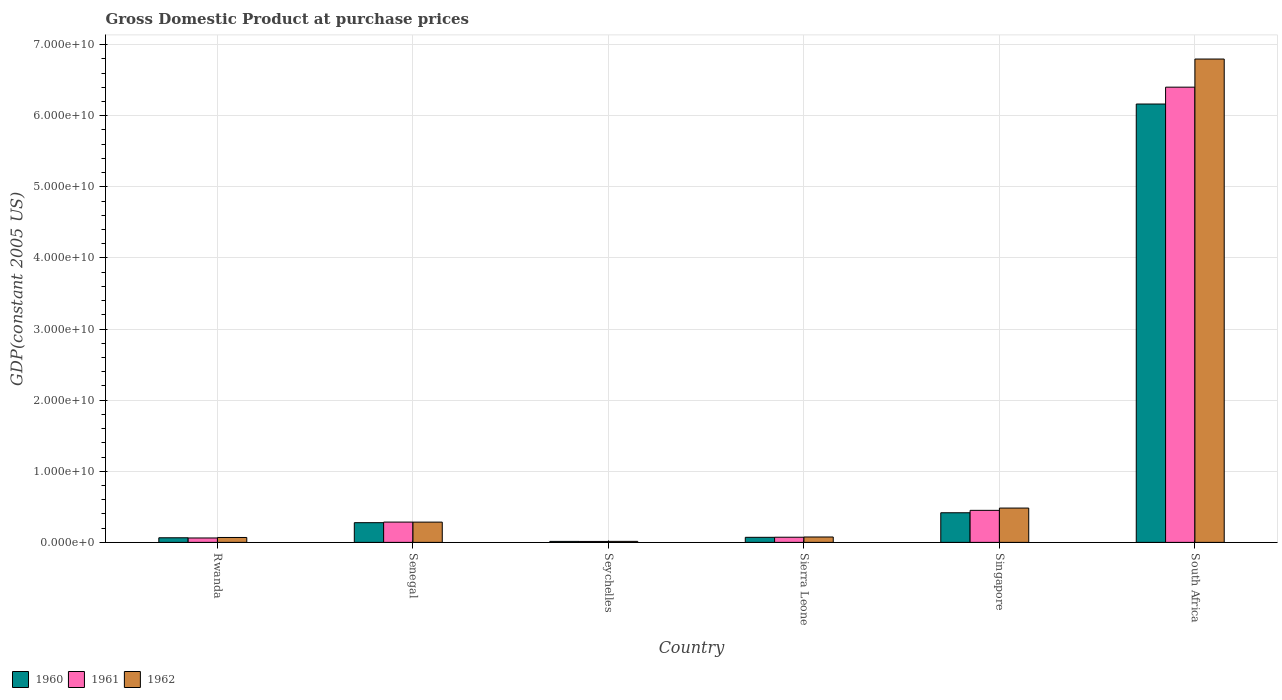How many different coloured bars are there?
Ensure brevity in your answer.  3. Are the number of bars per tick equal to the number of legend labels?
Provide a succinct answer. Yes. Are the number of bars on each tick of the X-axis equal?
Your response must be concise. Yes. How many bars are there on the 6th tick from the right?
Offer a terse response. 3. What is the label of the 2nd group of bars from the left?
Provide a succinct answer. Senegal. In how many cases, is the number of bars for a given country not equal to the number of legend labels?
Your response must be concise. 0. What is the GDP at purchase prices in 1960 in Sierra Leone?
Make the answer very short. 7.13e+08. Across all countries, what is the maximum GDP at purchase prices in 1962?
Offer a terse response. 6.80e+1. Across all countries, what is the minimum GDP at purchase prices in 1961?
Your answer should be very brief. 1.32e+08. In which country was the GDP at purchase prices in 1962 maximum?
Provide a short and direct response. South Africa. In which country was the GDP at purchase prices in 1962 minimum?
Your response must be concise. Seychelles. What is the total GDP at purchase prices in 1961 in the graph?
Your response must be concise. 7.28e+1. What is the difference between the GDP at purchase prices in 1961 in Senegal and that in Sierra Leone?
Give a very brief answer. 2.13e+09. What is the difference between the GDP at purchase prices in 1962 in Seychelles and the GDP at purchase prices in 1961 in Singapore?
Your response must be concise. -4.36e+09. What is the average GDP at purchase prices in 1961 per country?
Keep it short and to the point. 1.21e+1. What is the difference between the GDP at purchase prices of/in 1962 and GDP at purchase prices of/in 1961 in South Africa?
Offer a very short reply. 3.95e+09. In how many countries, is the GDP at purchase prices in 1960 greater than 38000000000 US$?
Give a very brief answer. 1. What is the ratio of the GDP at purchase prices in 1960 in Seychelles to that in Singapore?
Offer a very short reply. 0.03. Is the difference between the GDP at purchase prices in 1962 in Rwanda and Senegal greater than the difference between the GDP at purchase prices in 1961 in Rwanda and Senegal?
Keep it short and to the point. Yes. What is the difference between the highest and the second highest GDP at purchase prices in 1962?
Offer a terse response. -6.51e+1. What is the difference between the highest and the lowest GDP at purchase prices in 1961?
Offer a very short reply. 6.39e+1. What does the 2nd bar from the left in Seychelles represents?
Offer a very short reply. 1961. What does the 2nd bar from the right in Senegal represents?
Your answer should be compact. 1961. Are all the bars in the graph horizontal?
Offer a terse response. No. How many countries are there in the graph?
Offer a terse response. 6. What is the difference between two consecutive major ticks on the Y-axis?
Your response must be concise. 1.00e+1. Are the values on the major ticks of Y-axis written in scientific E-notation?
Offer a very short reply. Yes. How are the legend labels stacked?
Your answer should be compact. Horizontal. What is the title of the graph?
Your answer should be very brief. Gross Domestic Product at purchase prices. Does "1984" appear as one of the legend labels in the graph?
Offer a very short reply. No. What is the label or title of the Y-axis?
Ensure brevity in your answer.  GDP(constant 2005 US). What is the GDP(constant 2005 US) in 1960 in Rwanda?
Make the answer very short. 6.48e+08. What is the GDP(constant 2005 US) of 1961 in Rwanda?
Provide a succinct answer. 6.20e+08. What is the GDP(constant 2005 US) in 1962 in Rwanda?
Make the answer very short. 6.91e+08. What is the GDP(constant 2005 US) of 1960 in Senegal?
Keep it short and to the point. 2.77e+09. What is the GDP(constant 2005 US) in 1961 in Senegal?
Keep it short and to the point. 2.85e+09. What is the GDP(constant 2005 US) in 1962 in Senegal?
Your answer should be very brief. 2.85e+09. What is the GDP(constant 2005 US) in 1960 in Seychelles?
Keep it short and to the point. 1.39e+08. What is the GDP(constant 2005 US) in 1961 in Seychelles?
Your response must be concise. 1.32e+08. What is the GDP(constant 2005 US) of 1962 in Seychelles?
Make the answer very short. 1.43e+08. What is the GDP(constant 2005 US) in 1960 in Sierra Leone?
Offer a terse response. 7.13e+08. What is the GDP(constant 2005 US) of 1961 in Sierra Leone?
Provide a succinct answer. 7.25e+08. What is the GDP(constant 2005 US) of 1962 in Sierra Leone?
Give a very brief answer. 7.58e+08. What is the GDP(constant 2005 US) in 1960 in Singapore?
Provide a succinct answer. 4.17e+09. What is the GDP(constant 2005 US) of 1961 in Singapore?
Provide a succinct answer. 4.50e+09. What is the GDP(constant 2005 US) in 1962 in Singapore?
Offer a very short reply. 4.82e+09. What is the GDP(constant 2005 US) in 1960 in South Africa?
Your response must be concise. 6.16e+1. What is the GDP(constant 2005 US) of 1961 in South Africa?
Offer a very short reply. 6.40e+1. What is the GDP(constant 2005 US) of 1962 in South Africa?
Make the answer very short. 6.80e+1. Across all countries, what is the maximum GDP(constant 2005 US) of 1960?
Provide a succinct answer. 6.16e+1. Across all countries, what is the maximum GDP(constant 2005 US) in 1961?
Your response must be concise. 6.40e+1. Across all countries, what is the maximum GDP(constant 2005 US) in 1962?
Ensure brevity in your answer.  6.80e+1. Across all countries, what is the minimum GDP(constant 2005 US) in 1960?
Offer a terse response. 1.39e+08. Across all countries, what is the minimum GDP(constant 2005 US) in 1961?
Give a very brief answer. 1.32e+08. Across all countries, what is the minimum GDP(constant 2005 US) of 1962?
Provide a short and direct response. 1.43e+08. What is the total GDP(constant 2005 US) in 1960 in the graph?
Keep it short and to the point. 7.01e+1. What is the total GDP(constant 2005 US) of 1961 in the graph?
Your answer should be very brief. 7.28e+1. What is the total GDP(constant 2005 US) in 1962 in the graph?
Your answer should be compact. 7.72e+1. What is the difference between the GDP(constant 2005 US) in 1960 in Rwanda and that in Senegal?
Your answer should be compact. -2.12e+09. What is the difference between the GDP(constant 2005 US) in 1961 in Rwanda and that in Senegal?
Your answer should be compact. -2.23e+09. What is the difference between the GDP(constant 2005 US) of 1962 in Rwanda and that in Senegal?
Your answer should be compact. -2.16e+09. What is the difference between the GDP(constant 2005 US) in 1960 in Rwanda and that in Seychelles?
Provide a succinct answer. 5.10e+08. What is the difference between the GDP(constant 2005 US) in 1961 in Rwanda and that in Seychelles?
Provide a short and direct response. 4.89e+08. What is the difference between the GDP(constant 2005 US) of 1962 in Rwanda and that in Seychelles?
Your answer should be compact. 5.48e+08. What is the difference between the GDP(constant 2005 US) in 1960 in Rwanda and that in Sierra Leone?
Your answer should be very brief. -6.44e+07. What is the difference between the GDP(constant 2005 US) in 1961 in Rwanda and that in Sierra Leone?
Your response must be concise. -1.05e+08. What is the difference between the GDP(constant 2005 US) of 1962 in Rwanda and that in Sierra Leone?
Ensure brevity in your answer.  -6.77e+07. What is the difference between the GDP(constant 2005 US) in 1960 in Rwanda and that in Singapore?
Provide a short and direct response. -3.52e+09. What is the difference between the GDP(constant 2005 US) in 1961 in Rwanda and that in Singapore?
Provide a short and direct response. -3.88e+09. What is the difference between the GDP(constant 2005 US) in 1962 in Rwanda and that in Singapore?
Keep it short and to the point. -4.13e+09. What is the difference between the GDP(constant 2005 US) in 1960 in Rwanda and that in South Africa?
Make the answer very short. -6.10e+1. What is the difference between the GDP(constant 2005 US) in 1961 in Rwanda and that in South Africa?
Make the answer very short. -6.34e+1. What is the difference between the GDP(constant 2005 US) of 1962 in Rwanda and that in South Africa?
Give a very brief answer. -6.73e+1. What is the difference between the GDP(constant 2005 US) of 1960 in Senegal and that in Seychelles?
Offer a very short reply. 2.63e+09. What is the difference between the GDP(constant 2005 US) of 1961 in Senegal and that in Seychelles?
Your answer should be compact. 2.72e+09. What is the difference between the GDP(constant 2005 US) in 1962 in Senegal and that in Seychelles?
Your answer should be compact. 2.71e+09. What is the difference between the GDP(constant 2005 US) of 1960 in Senegal and that in Sierra Leone?
Provide a short and direct response. 2.06e+09. What is the difference between the GDP(constant 2005 US) of 1961 in Senegal and that in Sierra Leone?
Give a very brief answer. 2.13e+09. What is the difference between the GDP(constant 2005 US) of 1962 in Senegal and that in Sierra Leone?
Ensure brevity in your answer.  2.09e+09. What is the difference between the GDP(constant 2005 US) in 1960 in Senegal and that in Singapore?
Your answer should be very brief. -1.39e+09. What is the difference between the GDP(constant 2005 US) in 1961 in Senegal and that in Singapore?
Your answer should be compact. -1.65e+09. What is the difference between the GDP(constant 2005 US) of 1962 in Senegal and that in Singapore?
Offer a very short reply. -1.97e+09. What is the difference between the GDP(constant 2005 US) of 1960 in Senegal and that in South Africa?
Offer a very short reply. -5.89e+1. What is the difference between the GDP(constant 2005 US) in 1961 in Senegal and that in South Africa?
Offer a terse response. -6.12e+1. What is the difference between the GDP(constant 2005 US) in 1962 in Senegal and that in South Africa?
Keep it short and to the point. -6.51e+1. What is the difference between the GDP(constant 2005 US) of 1960 in Seychelles and that in Sierra Leone?
Provide a succinct answer. -5.74e+08. What is the difference between the GDP(constant 2005 US) in 1961 in Seychelles and that in Sierra Leone?
Ensure brevity in your answer.  -5.94e+08. What is the difference between the GDP(constant 2005 US) of 1962 in Seychelles and that in Sierra Leone?
Ensure brevity in your answer.  -6.16e+08. What is the difference between the GDP(constant 2005 US) of 1960 in Seychelles and that in Singapore?
Provide a short and direct response. -4.03e+09. What is the difference between the GDP(constant 2005 US) in 1961 in Seychelles and that in Singapore?
Your response must be concise. -4.37e+09. What is the difference between the GDP(constant 2005 US) of 1962 in Seychelles and that in Singapore?
Offer a terse response. -4.68e+09. What is the difference between the GDP(constant 2005 US) of 1960 in Seychelles and that in South Africa?
Your answer should be compact. -6.15e+1. What is the difference between the GDP(constant 2005 US) of 1961 in Seychelles and that in South Africa?
Provide a succinct answer. -6.39e+1. What is the difference between the GDP(constant 2005 US) in 1962 in Seychelles and that in South Africa?
Your answer should be very brief. -6.78e+1. What is the difference between the GDP(constant 2005 US) of 1960 in Sierra Leone and that in Singapore?
Your response must be concise. -3.45e+09. What is the difference between the GDP(constant 2005 US) in 1961 in Sierra Leone and that in Singapore?
Your answer should be very brief. -3.78e+09. What is the difference between the GDP(constant 2005 US) of 1962 in Sierra Leone and that in Singapore?
Offer a very short reply. -4.07e+09. What is the difference between the GDP(constant 2005 US) of 1960 in Sierra Leone and that in South Africa?
Your response must be concise. -6.09e+1. What is the difference between the GDP(constant 2005 US) in 1961 in Sierra Leone and that in South Africa?
Keep it short and to the point. -6.33e+1. What is the difference between the GDP(constant 2005 US) of 1962 in Sierra Leone and that in South Africa?
Your response must be concise. -6.72e+1. What is the difference between the GDP(constant 2005 US) of 1960 in Singapore and that in South Africa?
Your answer should be compact. -5.75e+1. What is the difference between the GDP(constant 2005 US) in 1961 in Singapore and that in South Africa?
Make the answer very short. -5.95e+1. What is the difference between the GDP(constant 2005 US) in 1962 in Singapore and that in South Africa?
Your answer should be very brief. -6.31e+1. What is the difference between the GDP(constant 2005 US) in 1960 in Rwanda and the GDP(constant 2005 US) in 1961 in Senegal?
Provide a short and direct response. -2.21e+09. What is the difference between the GDP(constant 2005 US) in 1960 in Rwanda and the GDP(constant 2005 US) in 1962 in Senegal?
Ensure brevity in your answer.  -2.20e+09. What is the difference between the GDP(constant 2005 US) of 1961 in Rwanda and the GDP(constant 2005 US) of 1962 in Senegal?
Keep it short and to the point. -2.23e+09. What is the difference between the GDP(constant 2005 US) of 1960 in Rwanda and the GDP(constant 2005 US) of 1961 in Seychelles?
Ensure brevity in your answer.  5.17e+08. What is the difference between the GDP(constant 2005 US) of 1960 in Rwanda and the GDP(constant 2005 US) of 1962 in Seychelles?
Offer a very short reply. 5.05e+08. What is the difference between the GDP(constant 2005 US) in 1961 in Rwanda and the GDP(constant 2005 US) in 1962 in Seychelles?
Your answer should be very brief. 4.78e+08. What is the difference between the GDP(constant 2005 US) of 1960 in Rwanda and the GDP(constant 2005 US) of 1961 in Sierra Leone?
Your answer should be compact. -7.72e+07. What is the difference between the GDP(constant 2005 US) of 1960 in Rwanda and the GDP(constant 2005 US) of 1962 in Sierra Leone?
Your answer should be very brief. -1.10e+08. What is the difference between the GDP(constant 2005 US) of 1961 in Rwanda and the GDP(constant 2005 US) of 1962 in Sierra Leone?
Provide a short and direct response. -1.38e+08. What is the difference between the GDP(constant 2005 US) of 1960 in Rwanda and the GDP(constant 2005 US) of 1961 in Singapore?
Your answer should be very brief. -3.86e+09. What is the difference between the GDP(constant 2005 US) in 1960 in Rwanda and the GDP(constant 2005 US) in 1962 in Singapore?
Offer a terse response. -4.18e+09. What is the difference between the GDP(constant 2005 US) in 1961 in Rwanda and the GDP(constant 2005 US) in 1962 in Singapore?
Your answer should be compact. -4.20e+09. What is the difference between the GDP(constant 2005 US) in 1960 in Rwanda and the GDP(constant 2005 US) in 1961 in South Africa?
Offer a terse response. -6.34e+1. What is the difference between the GDP(constant 2005 US) in 1960 in Rwanda and the GDP(constant 2005 US) in 1962 in South Africa?
Offer a very short reply. -6.73e+1. What is the difference between the GDP(constant 2005 US) of 1961 in Rwanda and the GDP(constant 2005 US) of 1962 in South Africa?
Your answer should be very brief. -6.73e+1. What is the difference between the GDP(constant 2005 US) of 1960 in Senegal and the GDP(constant 2005 US) of 1961 in Seychelles?
Your response must be concise. 2.64e+09. What is the difference between the GDP(constant 2005 US) of 1960 in Senegal and the GDP(constant 2005 US) of 1962 in Seychelles?
Offer a very short reply. 2.63e+09. What is the difference between the GDP(constant 2005 US) in 1961 in Senegal and the GDP(constant 2005 US) in 1962 in Seychelles?
Your response must be concise. 2.71e+09. What is the difference between the GDP(constant 2005 US) of 1960 in Senegal and the GDP(constant 2005 US) of 1961 in Sierra Leone?
Offer a terse response. 2.05e+09. What is the difference between the GDP(constant 2005 US) of 1960 in Senegal and the GDP(constant 2005 US) of 1962 in Sierra Leone?
Keep it short and to the point. 2.01e+09. What is the difference between the GDP(constant 2005 US) of 1961 in Senegal and the GDP(constant 2005 US) of 1962 in Sierra Leone?
Provide a short and direct response. 2.10e+09. What is the difference between the GDP(constant 2005 US) in 1960 in Senegal and the GDP(constant 2005 US) in 1961 in Singapore?
Ensure brevity in your answer.  -1.73e+09. What is the difference between the GDP(constant 2005 US) in 1960 in Senegal and the GDP(constant 2005 US) in 1962 in Singapore?
Keep it short and to the point. -2.05e+09. What is the difference between the GDP(constant 2005 US) in 1961 in Senegal and the GDP(constant 2005 US) in 1962 in Singapore?
Give a very brief answer. -1.97e+09. What is the difference between the GDP(constant 2005 US) of 1960 in Senegal and the GDP(constant 2005 US) of 1961 in South Africa?
Your answer should be very brief. -6.12e+1. What is the difference between the GDP(constant 2005 US) of 1960 in Senegal and the GDP(constant 2005 US) of 1962 in South Africa?
Your answer should be compact. -6.52e+1. What is the difference between the GDP(constant 2005 US) of 1961 in Senegal and the GDP(constant 2005 US) of 1962 in South Africa?
Give a very brief answer. -6.51e+1. What is the difference between the GDP(constant 2005 US) of 1960 in Seychelles and the GDP(constant 2005 US) of 1961 in Sierra Leone?
Make the answer very short. -5.87e+08. What is the difference between the GDP(constant 2005 US) in 1960 in Seychelles and the GDP(constant 2005 US) in 1962 in Sierra Leone?
Provide a succinct answer. -6.20e+08. What is the difference between the GDP(constant 2005 US) in 1961 in Seychelles and the GDP(constant 2005 US) in 1962 in Sierra Leone?
Your answer should be very brief. -6.27e+08. What is the difference between the GDP(constant 2005 US) of 1960 in Seychelles and the GDP(constant 2005 US) of 1961 in Singapore?
Keep it short and to the point. -4.37e+09. What is the difference between the GDP(constant 2005 US) in 1960 in Seychelles and the GDP(constant 2005 US) in 1962 in Singapore?
Your answer should be very brief. -4.69e+09. What is the difference between the GDP(constant 2005 US) of 1961 in Seychelles and the GDP(constant 2005 US) of 1962 in Singapore?
Your answer should be very brief. -4.69e+09. What is the difference between the GDP(constant 2005 US) of 1960 in Seychelles and the GDP(constant 2005 US) of 1961 in South Africa?
Your answer should be compact. -6.39e+1. What is the difference between the GDP(constant 2005 US) in 1960 in Seychelles and the GDP(constant 2005 US) in 1962 in South Africa?
Your answer should be compact. -6.78e+1. What is the difference between the GDP(constant 2005 US) of 1961 in Seychelles and the GDP(constant 2005 US) of 1962 in South Africa?
Keep it short and to the point. -6.78e+1. What is the difference between the GDP(constant 2005 US) in 1960 in Sierra Leone and the GDP(constant 2005 US) in 1961 in Singapore?
Provide a short and direct response. -3.79e+09. What is the difference between the GDP(constant 2005 US) in 1960 in Sierra Leone and the GDP(constant 2005 US) in 1962 in Singapore?
Give a very brief answer. -4.11e+09. What is the difference between the GDP(constant 2005 US) of 1961 in Sierra Leone and the GDP(constant 2005 US) of 1962 in Singapore?
Your response must be concise. -4.10e+09. What is the difference between the GDP(constant 2005 US) of 1960 in Sierra Leone and the GDP(constant 2005 US) of 1961 in South Africa?
Give a very brief answer. -6.33e+1. What is the difference between the GDP(constant 2005 US) of 1960 in Sierra Leone and the GDP(constant 2005 US) of 1962 in South Africa?
Provide a succinct answer. -6.73e+1. What is the difference between the GDP(constant 2005 US) in 1961 in Sierra Leone and the GDP(constant 2005 US) in 1962 in South Africa?
Provide a succinct answer. -6.72e+1. What is the difference between the GDP(constant 2005 US) of 1960 in Singapore and the GDP(constant 2005 US) of 1961 in South Africa?
Keep it short and to the point. -5.98e+1. What is the difference between the GDP(constant 2005 US) of 1960 in Singapore and the GDP(constant 2005 US) of 1962 in South Africa?
Your answer should be compact. -6.38e+1. What is the difference between the GDP(constant 2005 US) in 1961 in Singapore and the GDP(constant 2005 US) in 1962 in South Africa?
Offer a very short reply. -6.35e+1. What is the average GDP(constant 2005 US) in 1960 per country?
Offer a terse response. 1.17e+1. What is the average GDP(constant 2005 US) in 1961 per country?
Ensure brevity in your answer.  1.21e+1. What is the average GDP(constant 2005 US) in 1962 per country?
Your response must be concise. 1.29e+1. What is the difference between the GDP(constant 2005 US) of 1960 and GDP(constant 2005 US) of 1961 in Rwanda?
Provide a succinct answer. 2.79e+07. What is the difference between the GDP(constant 2005 US) in 1960 and GDP(constant 2005 US) in 1962 in Rwanda?
Offer a terse response. -4.25e+07. What is the difference between the GDP(constant 2005 US) in 1961 and GDP(constant 2005 US) in 1962 in Rwanda?
Your answer should be very brief. -7.03e+07. What is the difference between the GDP(constant 2005 US) in 1960 and GDP(constant 2005 US) in 1961 in Senegal?
Provide a short and direct response. -8.29e+07. What is the difference between the GDP(constant 2005 US) in 1960 and GDP(constant 2005 US) in 1962 in Senegal?
Ensure brevity in your answer.  -7.91e+07. What is the difference between the GDP(constant 2005 US) of 1961 and GDP(constant 2005 US) of 1962 in Senegal?
Your answer should be very brief. 3.89e+06. What is the difference between the GDP(constant 2005 US) of 1960 and GDP(constant 2005 US) of 1961 in Seychelles?
Provide a short and direct response. 6.76e+06. What is the difference between the GDP(constant 2005 US) in 1960 and GDP(constant 2005 US) in 1962 in Seychelles?
Provide a short and direct response. -4.32e+06. What is the difference between the GDP(constant 2005 US) in 1961 and GDP(constant 2005 US) in 1962 in Seychelles?
Your answer should be very brief. -1.11e+07. What is the difference between the GDP(constant 2005 US) of 1960 and GDP(constant 2005 US) of 1961 in Sierra Leone?
Provide a short and direct response. -1.29e+07. What is the difference between the GDP(constant 2005 US) in 1960 and GDP(constant 2005 US) in 1962 in Sierra Leone?
Your answer should be compact. -4.58e+07. What is the difference between the GDP(constant 2005 US) of 1961 and GDP(constant 2005 US) of 1962 in Sierra Leone?
Provide a short and direct response. -3.29e+07. What is the difference between the GDP(constant 2005 US) of 1960 and GDP(constant 2005 US) of 1961 in Singapore?
Provide a short and direct response. -3.39e+08. What is the difference between the GDP(constant 2005 US) in 1960 and GDP(constant 2005 US) in 1962 in Singapore?
Offer a terse response. -6.60e+08. What is the difference between the GDP(constant 2005 US) in 1961 and GDP(constant 2005 US) in 1962 in Singapore?
Ensure brevity in your answer.  -3.21e+08. What is the difference between the GDP(constant 2005 US) in 1960 and GDP(constant 2005 US) in 1961 in South Africa?
Provide a succinct answer. -2.37e+09. What is the difference between the GDP(constant 2005 US) of 1960 and GDP(constant 2005 US) of 1962 in South Africa?
Provide a succinct answer. -6.32e+09. What is the difference between the GDP(constant 2005 US) of 1961 and GDP(constant 2005 US) of 1962 in South Africa?
Keep it short and to the point. -3.95e+09. What is the ratio of the GDP(constant 2005 US) in 1960 in Rwanda to that in Senegal?
Ensure brevity in your answer.  0.23. What is the ratio of the GDP(constant 2005 US) of 1961 in Rwanda to that in Senegal?
Offer a terse response. 0.22. What is the ratio of the GDP(constant 2005 US) of 1962 in Rwanda to that in Senegal?
Give a very brief answer. 0.24. What is the ratio of the GDP(constant 2005 US) in 1960 in Rwanda to that in Seychelles?
Your answer should be compact. 4.68. What is the ratio of the GDP(constant 2005 US) of 1961 in Rwanda to that in Seychelles?
Your answer should be very brief. 4.71. What is the ratio of the GDP(constant 2005 US) in 1962 in Rwanda to that in Seychelles?
Your response must be concise. 4.84. What is the ratio of the GDP(constant 2005 US) of 1960 in Rwanda to that in Sierra Leone?
Ensure brevity in your answer.  0.91. What is the ratio of the GDP(constant 2005 US) of 1961 in Rwanda to that in Sierra Leone?
Keep it short and to the point. 0.86. What is the ratio of the GDP(constant 2005 US) of 1962 in Rwanda to that in Sierra Leone?
Your response must be concise. 0.91. What is the ratio of the GDP(constant 2005 US) in 1960 in Rwanda to that in Singapore?
Provide a succinct answer. 0.16. What is the ratio of the GDP(constant 2005 US) in 1961 in Rwanda to that in Singapore?
Your answer should be very brief. 0.14. What is the ratio of the GDP(constant 2005 US) of 1962 in Rwanda to that in Singapore?
Provide a short and direct response. 0.14. What is the ratio of the GDP(constant 2005 US) in 1960 in Rwanda to that in South Africa?
Offer a very short reply. 0.01. What is the ratio of the GDP(constant 2005 US) of 1961 in Rwanda to that in South Africa?
Offer a terse response. 0.01. What is the ratio of the GDP(constant 2005 US) of 1962 in Rwanda to that in South Africa?
Make the answer very short. 0.01. What is the ratio of the GDP(constant 2005 US) in 1960 in Senegal to that in Seychelles?
Make the answer very short. 20.01. What is the ratio of the GDP(constant 2005 US) of 1961 in Senegal to that in Seychelles?
Offer a terse response. 21.66. What is the ratio of the GDP(constant 2005 US) in 1962 in Senegal to that in Seychelles?
Ensure brevity in your answer.  19.96. What is the ratio of the GDP(constant 2005 US) of 1960 in Senegal to that in Sierra Leone?
Your answer should be very brief. 3.89. What is the ratio of the GDP(constant 2005 US) of 1961 in Senegal to that in Sierra Leone?
Your response must be concise. 3.93. What is the ratio of the GDP(constant 2005 US) of 1962 in Senegal to that in Sierra Leone?
Provide a short and direct response. 3.76. What is the ratio of the GDP(constant 2005 US) of 1960 in Senegal to that in Singapore?
Provide a succinct answer. 0.67. What is the ratio of the GDP(constant 2005 US) in 1961 in Senegal to that in Singapore?
Make the answer very short. 0.63. What is the ratio of the GDP(constant 2005 US) in 1962 in Senegal to that in Singapore?
Make the answer very short. 0.59. What is the ratio of the GDP(constant 2005 US) of 1960 in Senegal to that in South Africa?
Give a very brief answer. 0.04. What is the ratio of the GDP(constant 2005 US) of 1961 in Senegal to that in South Africa?
Provide a short and direct response. 0.04. What is the ratio of the GDP(constant 2005 US) in 1962 in Senegal to that in South Africa?
Ensure brevity in your answer.  0.04. What is the ratio of the GDP(constant 2005 US) in 1960 in Seychelles to that in Sierra Leone?
Offer a terse response. 0.19. What is the ratio of the GDP(constant 2005 US) in 1961 in Seychelles to that in Sierra Leone?
Your answer should be compact. 0.18. What is the ratio of the GDP(constant 2005 US) in 1962 in Seychelles to that in Sierra Leone?
Your response must be concise. 0.19. What is the ratio of the GDP(constant 2005 US) of 1960 in Seychelles to that in Singapore?
Offer a very short reply. 0.03. What is the ratio of the GDP(constant 2005 US) of 1961 in Seychelles to that in Singapore?
Give a very brief answer. 0.03. What is the ratio of the GDP(constant 2005 US) in 1962 in Seychelles to that in Singapore?
Offer a very short reply. 0.03. What is the ratio of the GDP(constant 2005 US) in 1960 in Seychelles to that in South Africa?
Your answer should be compact. 0. What is the ratio of the GDP(constant 2005 US) of 1961 in Seychelles to that in South Africa?
Provide a short and direct response. 0. What is the ratio of the GDP(constant 2005 US) of 1962 in Seychelles to that in South Africa?
Provide a succinct answer. 0. What is the ratio of the GDP(constant 2005 US) of 1960 in Sierra Leone to that in Singapore?
Offer a very short reply. 0.17. What is the ratio of the GDP(constant 2005 US) of 1961 in Sierra Leone to that in Singapore?
Keep it short and to the point. 0.16. What is the ratio of the GDP(constant 2005 US) in 1962 in Sierra Leone to that in Singapore?
Your response must be concise. 0.16. What is the ratio of the GDP(constant 2005 US) in 1960 in Sierra Leone to that in South Africa?
Your answer should be compact. 0.01. What is the ratio of the GDP(constant 2005 US) of 1961 in Sierra Leone to that in South Africa?
Your answer should be compact. 0.01. What is the ratio of the GDP(constant 2005 US) in 1962 in Sierra Leone to that in South Africa?
Provide a short and direct response. 0.01. What is the ratio of the GDP(constant 2005 US) of 1960 in Singapore to that in South Africa?
Your answer should be compact. 0.07. What is the ratio of the GDP(constant 2005 US) in 1961 in Singapore to that in South Africa?
Your answer should be very brief. 0.07. What is the ratio of the GDP(constant 2005 US) in 1962 in Singapore to that in South Africa?
Offer a terse response. 0.07. What is the difference between the highest and the second highest GDP(constant 2005 US) in 1960?
Give a very brief answer. 5.75e+1. What is the difference between the highest and the second highest GDP(constant 2005 US) in 1961?
Offer a terse response. 5.95e+1. What is the difference between the highest and the second highest GDP(constant 2005 US) in 1962?
Offer a very short reply. 6.31e+1. What is the difference between the highest and the lowest GDP(constant 2005 US) in 1960?
Make the answer very short. 6.15e+1. What is the difference between the highest and the lowest GDP(constant 2005 US) in 1961?
Your answer should be compact. 6.39e+1. What is the difference between the highest and the lowest GDP(constant 2005 US) of 1962?
Your answer should be compact. 6.78e+1. 